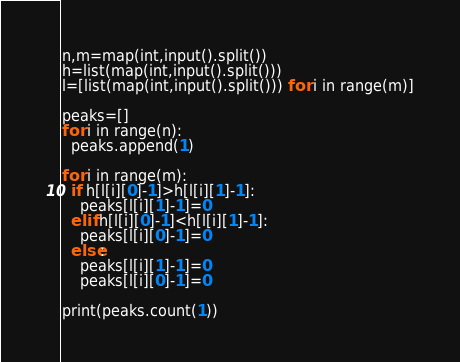Convert code to text. <code><loc_0><loc_0><loc_500><loc_500><_Python_>n,m=map(int,input().split())
h=list(map(int,input().split()))
l=[list(map(int,input().split())) for i in range(m)]

peaks=[]
for i in range(n):
  peaks.append(1)
  
for i in range(m):
  if h[l[i][0]-1]>h[l[i][1]-1]:
    peaks[l[i][1]-1]=0
  elif h[l[i][0]-1]<h[l[i][1]-1]:
    peaks[l[i][0]-1]=0
  else:
    peaks[l[i][1]-1]=0
    peaks[l[i][0]-1]=0

print(peaks.count(1))</code> 